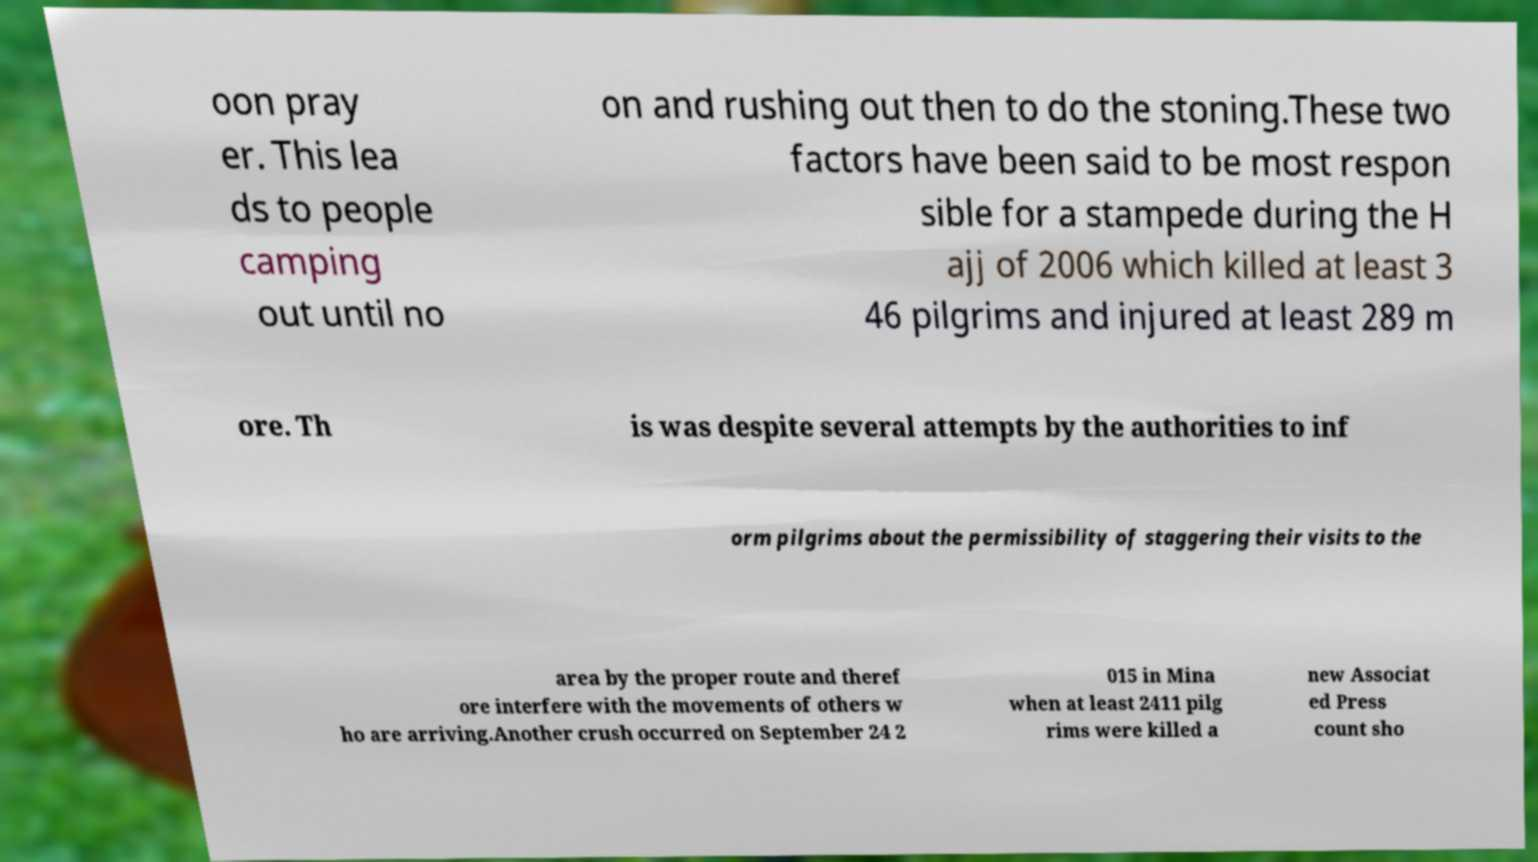I need the written content from this picture converted into text. Can you do that? oon pray er. This lea ds to people camping out until no on and rushing out then to do the stoning.These two factors have been said to be most respon sible for a stampede during the H ajj of 2006 which killed at least 3 46 pilgrims and injured at least 289 m ore. Th is was despite several attempts by the authorities to inf orm pilgrims about the permissibility of staggering their visits to the area by the proper route and theref ore interfere with the movements of others w ho are arriving.Another crush occurred on September 24 2 015 in Mina when at least 2411 pilg rims were killed a new Associat ed Press count sho 